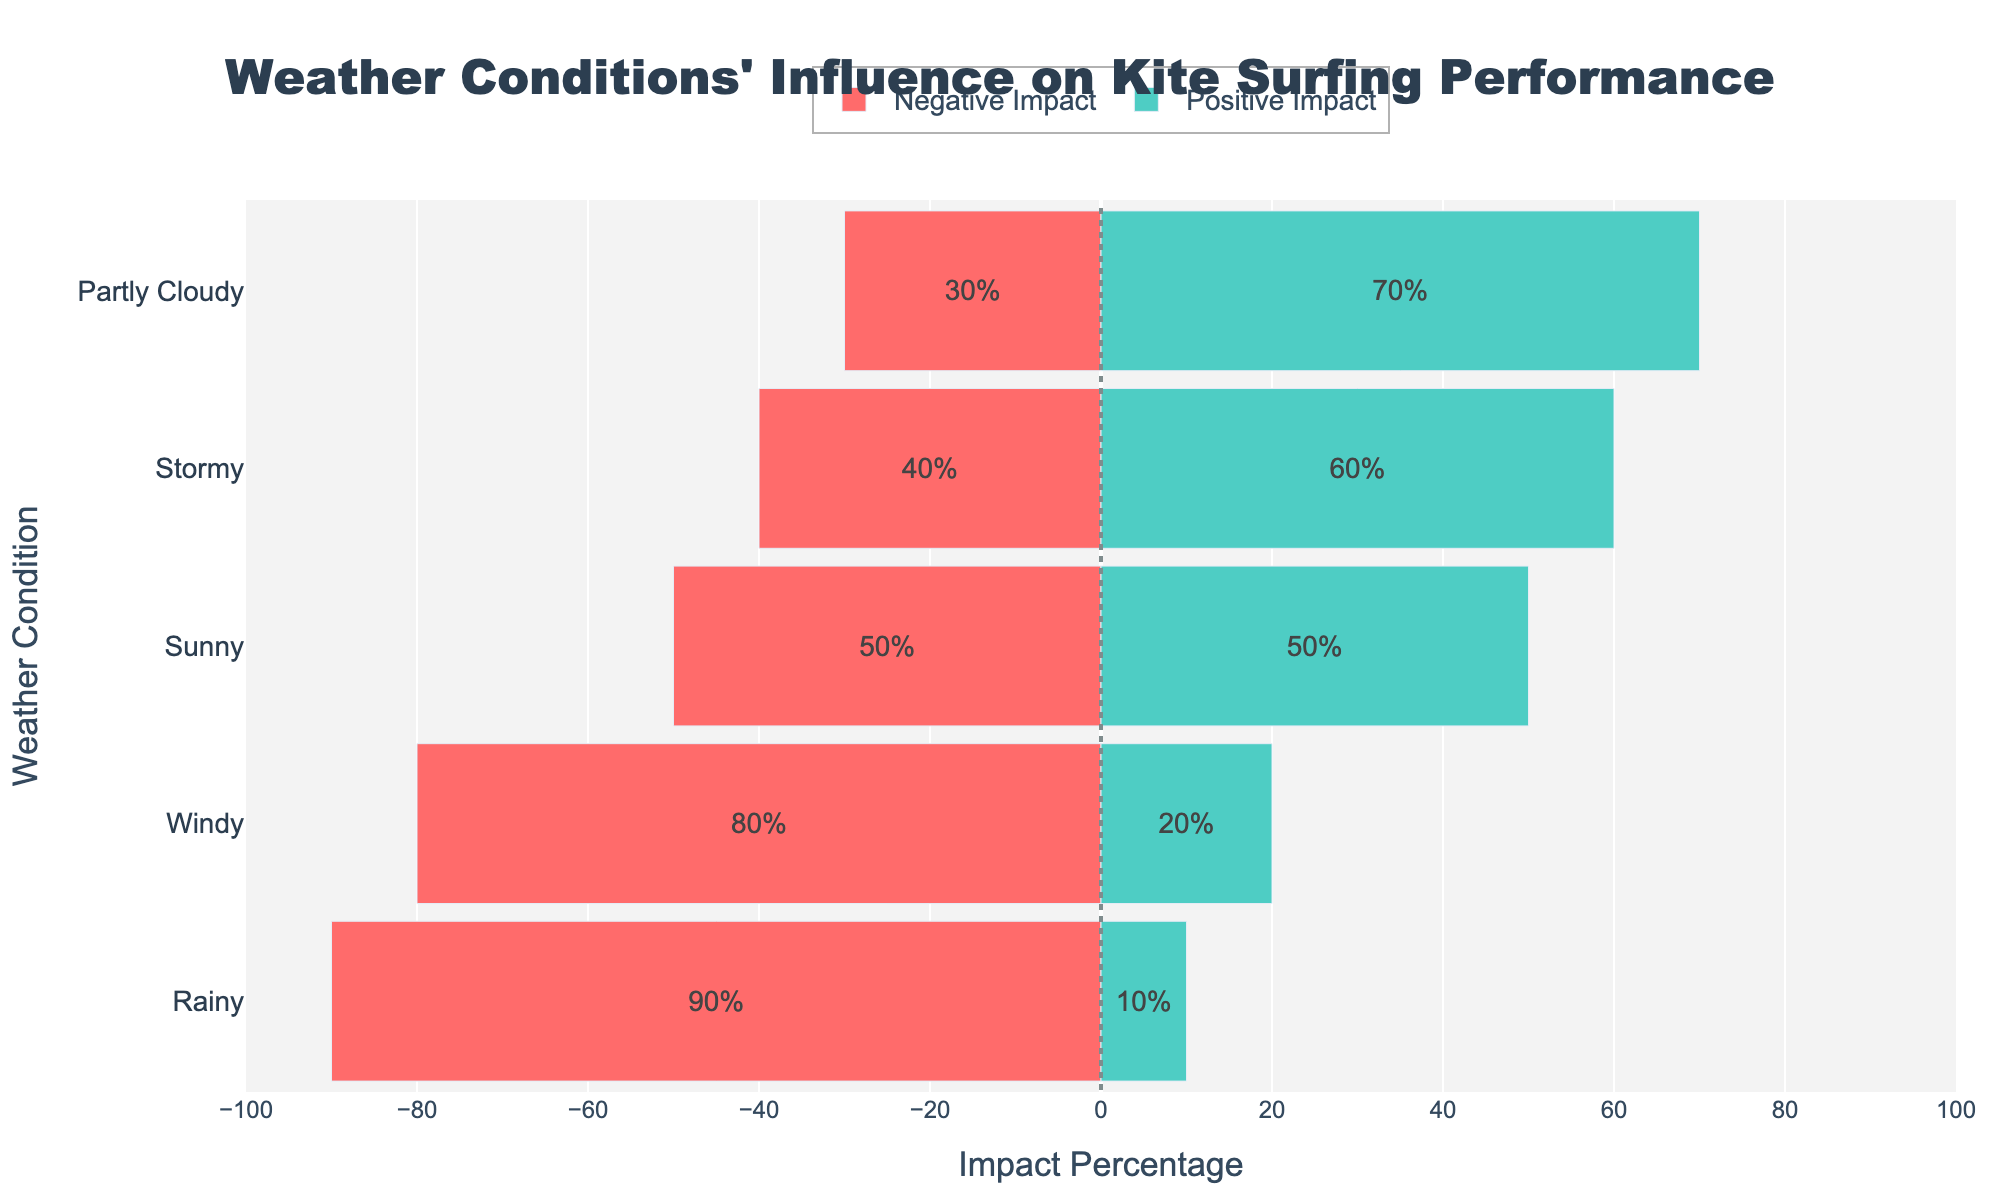Which weather condition has the highest positive impact on kite surfing performance? Look at the bar with the longest green section representing positive impact percentages. The 'Sunny' condition has the longest green bar with 70%.
Answer: Sunny Which weather condition has the highest negative impact on kite surfing performance? Look at the bar with the longest red section representing negative impact percentages. The 'Stormy' condition has the longest red bar with 90%.
Answer: Stormy How many weather conditions have an equal percentage of positive and negative impacts? Check bars where the green and red sections seem to be of equal length or have percentages summing up equally. Only 'Partly Cloudy' shows an even split.
Answer: 1 What is the net positive impact percentage for 'Windy' and 'Sunny' combined? Summing the positive impact percentages of each condition: Windy (60%) + Sunny (70%) = 130%.
Answer: 130% Compare the negative impact of 'Rainy' and 'Partly Cloudy' conditions. Which one is higher and by how much? Rainy has 80% negative impact, and Partly Cloudy has 50%. The difference is 80% - 50% = 30%.
Answer: Rainy, by 30% What is the overall positive impact percentage of all weather conditions? Summing the positive impact percentages of all conditions: Sunny (70%) + Windy (60%) + Rainy (20%) + Partly Cloudy (50%) + Stormy (10%) = 210%.
Answer: 210% What does the color red represent in the chart? The color red is used to represent the negative impact percentage of the weather conditions on kite surfing performance.
Answer: Negative impact 